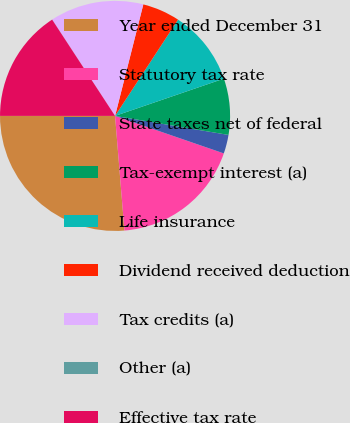Convert chart to OTSL. <chart><loc_0><loc_0><loc_500><loc_500><pie_chart><fcel>Year ended December 31<fcel>Statutory tax rate<fcel>State taxes net of federal<fcel>Tax-exempt interest (a)<fcel>Life insurance<fcel>Dividend received deduction<fcel>Tax credits (a)<fcel>Other (a)<fcel>Effective tax rate<nl><fcel>26.31%<fcel>18.42%<fcel>2.64%<fcel>7.9%<fcel>10.53%<fcel>5.27%<fcel>13.16%<fcel>0.01%<fcel>15.79%<nl></chart> 